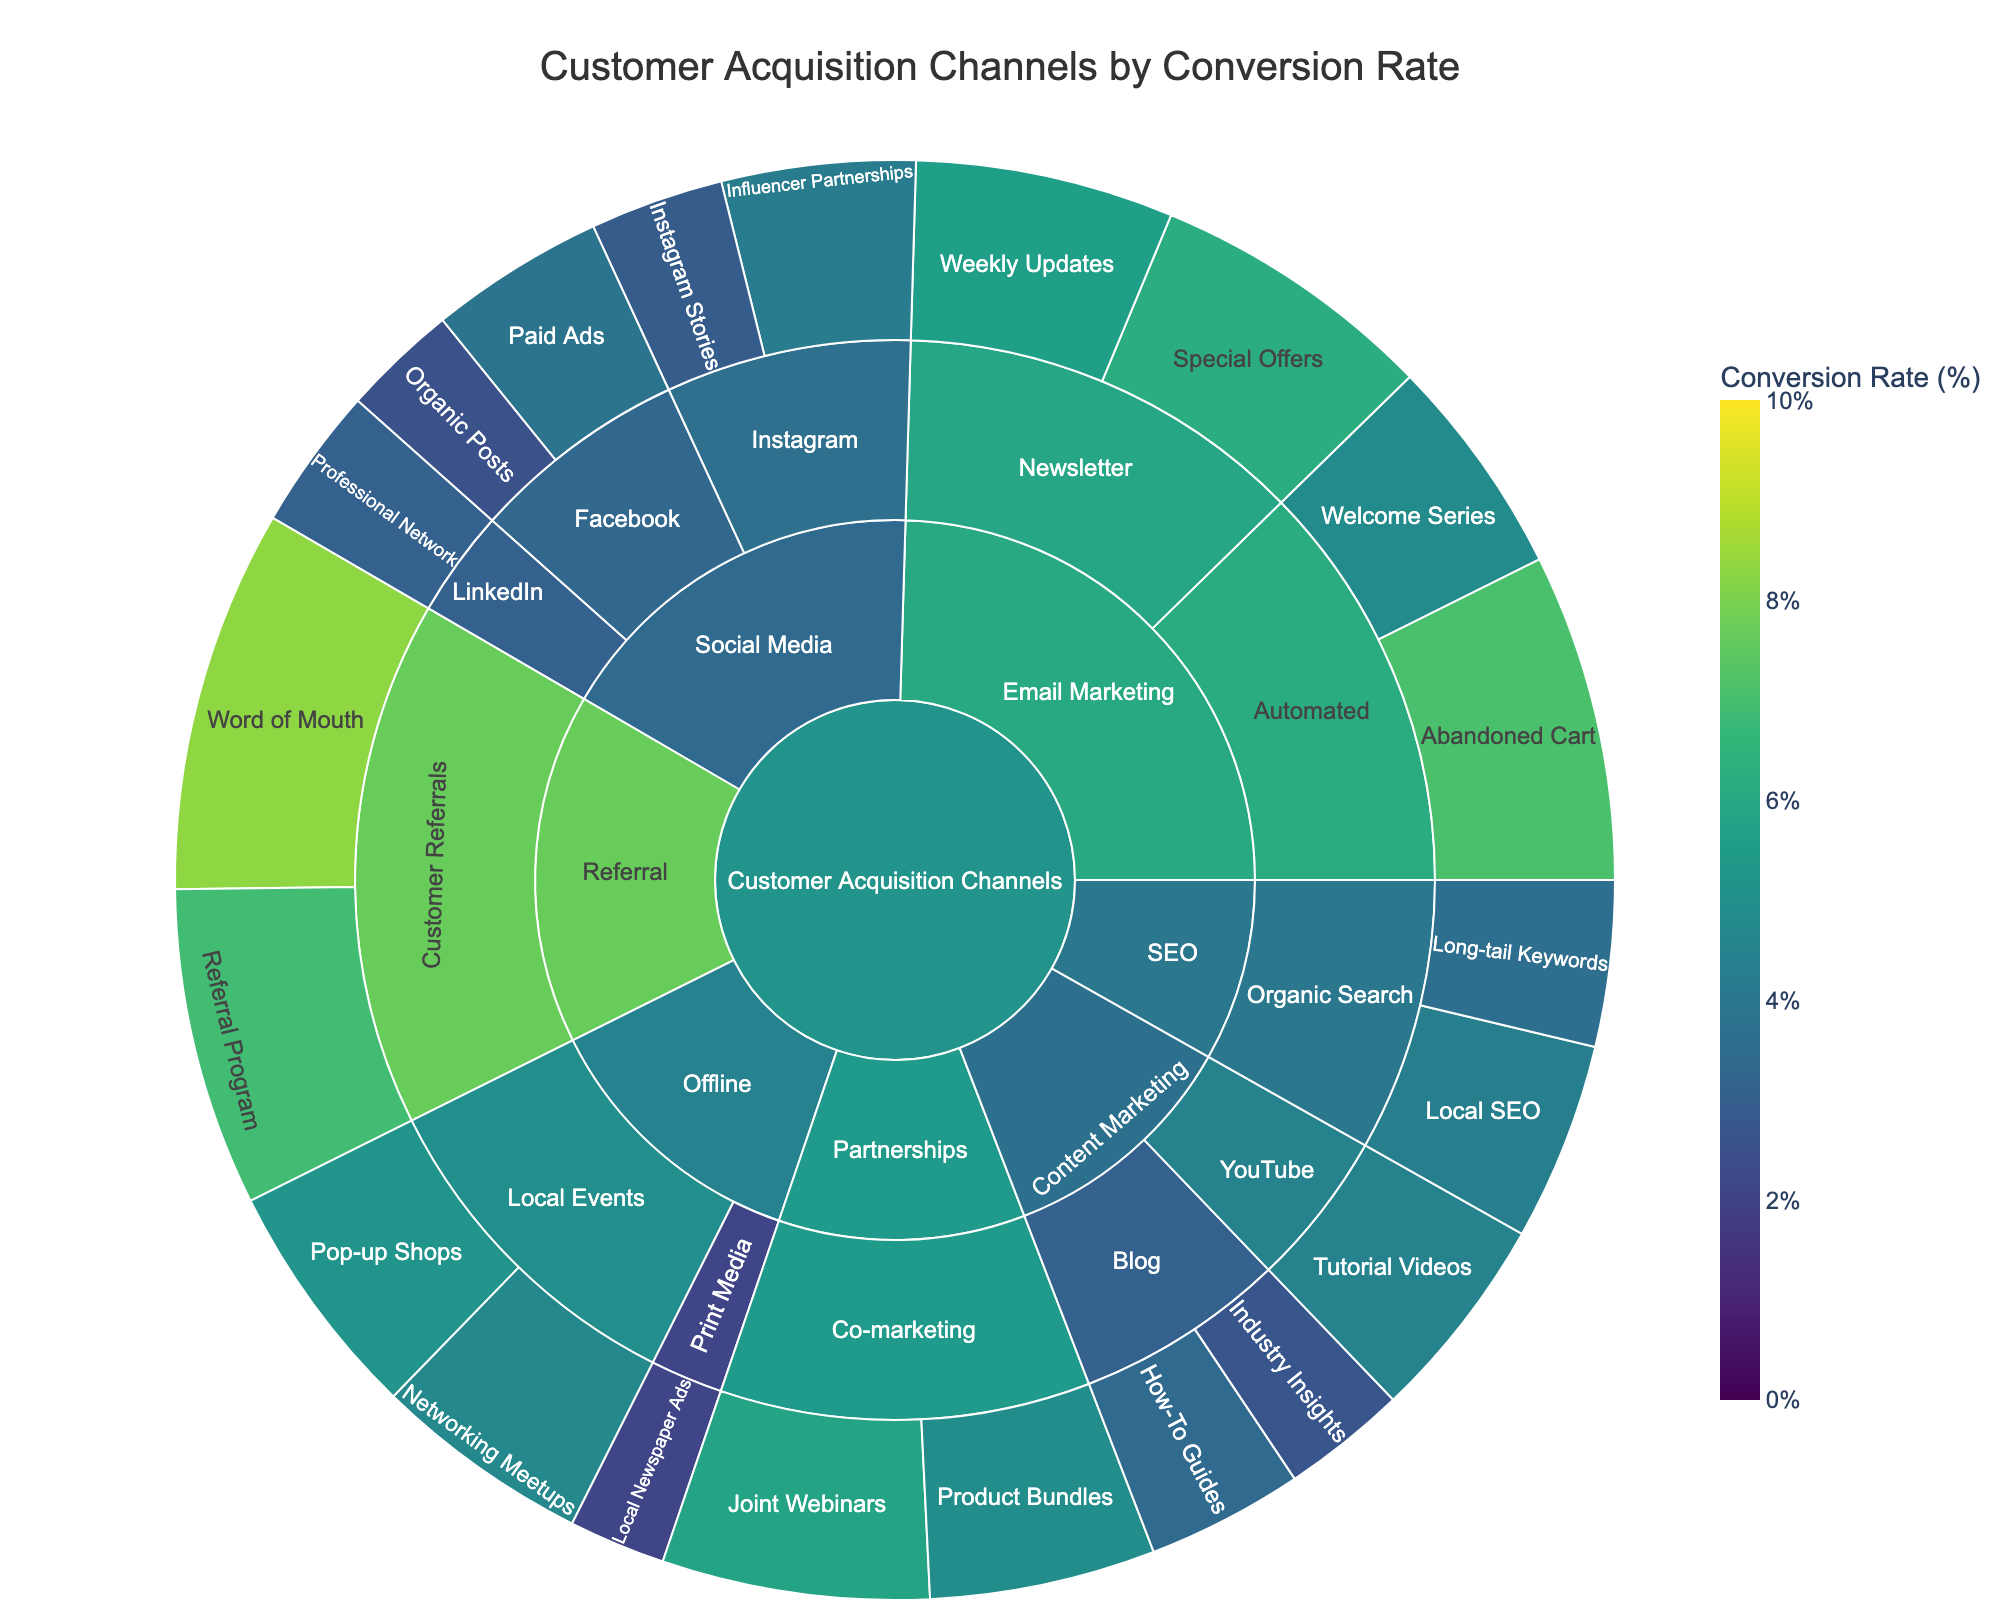What is the title of the Sunburst Plot? The title is clearly displayed at the top center of the figure, just below the margin.
Answer: Customer Acquisition Channels by Conversion Rate Which category has the highest conversion rate and what is it? Go to each category level, look for the highest conversion rate indicated by the color intensity and read the exact value from the hover details. The darkest/most intense color in the "Referral" category shows the highest conversion rate.
Answer: Referral, 8.3% Among Email Marketing tactics, which one has the highest conversion rate and what is the value? Navigate through the "Email Marketing" category, locate each tactic under its subcategories, and identify the highest conversion rate from the hover details.
Answer: Abandoned Cart, 7.1% What is the conversion rate for Local Events tactics in the Offline category? Move to the "Offline" category, then look for the "Local Events" tactics and sum their conversion rates from the hover details.
Answer: Pop-up Shops: 5.2%, Networking Meetups: 4.7% How does the conversion rate of Influencer Partnerships compare to Paid Ads on Facebook? Locate "Influencer Partnerships" under Instagram and "Paid Ads" under Facebook; compare their conversion rates. Influencer Partnerships has a higher conversion rate.
Answer: 4.2% > 3.8% What is the average conversion rate for SEO tactics? Navigate to the "SEO" category, extract the conversion rates for "Long-tail Keywords" and "Local SEO," then compute the average.
Answer: (3.6 + 4.3) / 2 = 3.95% Count the number of distinct marketing tactics in the Content Marketing category. Move to the "Content Marketing" category and count the distinct types of tactics listed under each subcategory.
Answer: 3 (How-To Guides, Industry Insights, Tutorial Videos) Which tactic under Email Marketing has almost the same conversion rate as Abandoned Cart under Automated tactics? Find "Abandoned Cart" under "Automated" in Email Marketing and then compare it with other Email Marketing tactics to find a similar rate. "Special Offers" under Newsletter has a close rate.
Answer: Special Offers, 6.2% Is the conversion rate for Local Newspaper Ads higher or lower than Organic Posts on Facebook? Navigate to "Print Media" under "Offline" for Local Newspaper Ads and to "Organic Posts" under "Facebook" in Social Media, then compare. The rate for Local Newspaper Ads is lower.
Answer: 2.1% < 2.5% What is the sum of conversion rates for tactics under the Partnerships category? Access the "Partnerships" category, find the conversion rates for "Joint Webinars" and "Product Bundles," and sum them up.
Answer: 5.8 + 4.9 = 10.7 